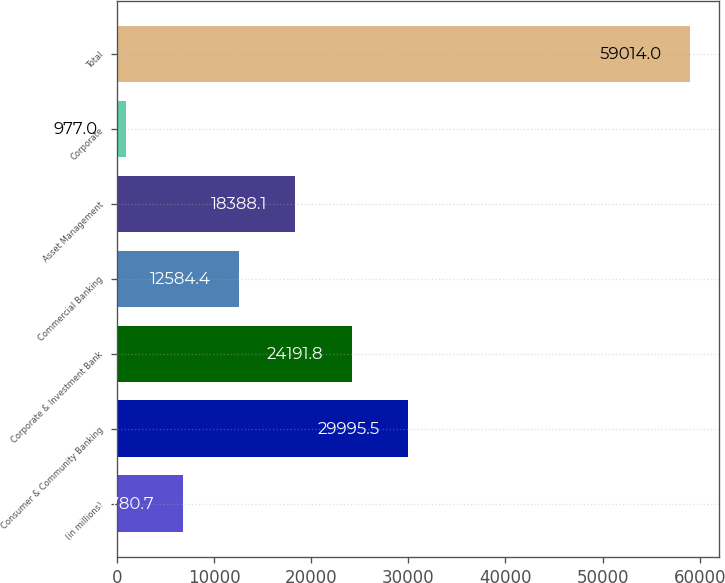Convert chart to OTSL. <chart><loc_0><loc_0><loc_500><loc_500><bar_chart><fcel>(in millions)<fcel>Consumer & Community Banking<fcel>Corporate & Investment Bank<fcel>Commercial Banking<fcel>Asset Management<fcel>Corporate<fcel>Total<nl><fcel>6780.7<fcel>29995.5<fcel>24191.8<fcel>12584.4<fcel>18388.1<fcel>977<fcel>59014<nl></chart> 